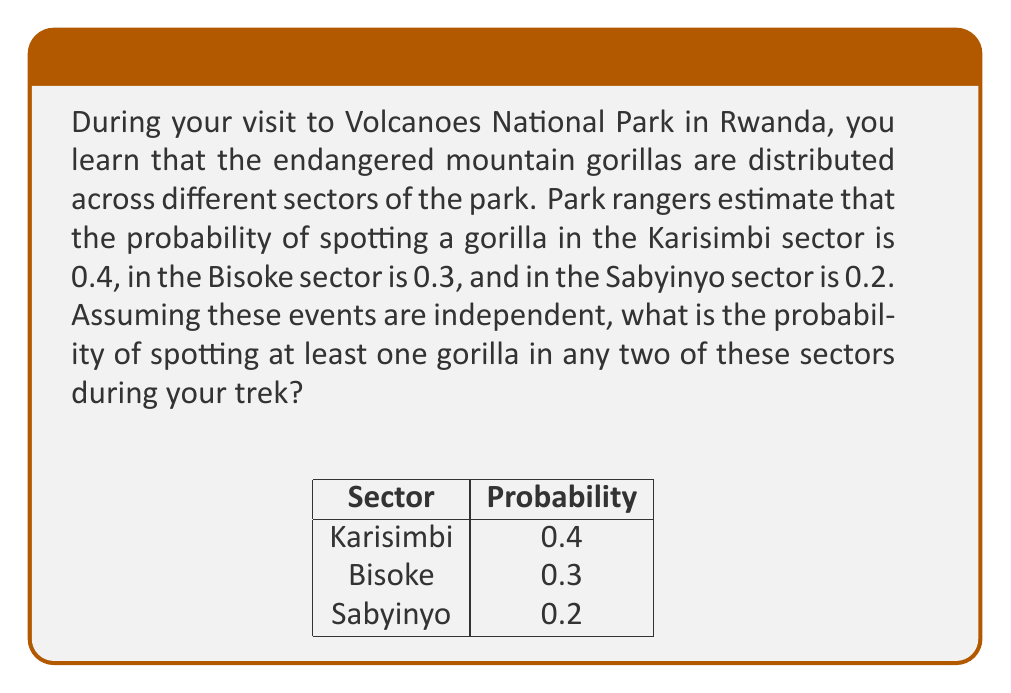Can you answer this question? Let's approach this step-by-step:

1) First, let's define our events:
   K: Spotting a gorilla in Karisimbi sector
   B: Spotting a gorilla in Bisoke sector
   S: Spotting a gorilla in Sabyinyo sector

2) We're given the following probabilities:
   P(K) = 0.4
   P(B) = 0.3
   P(S) = 0.2

3) We need to find the probability of spotting a gorilla in at least two sectors. It's easier to calculate the complement of this event: the probability of spotting a gorilla in one or zero sectors.

4) The probability of not spotting a gorilla in a sector is:
   P(not K) = 1 - 0.4 = 0.6
   P(not B) = 1 - 0.3 = 0.7
   P(not S) = 1 - 0.2 = 0.8

5) The probability of spotting no gorillas at all:
   P(no gorillas) = P(not K) × P(not B) × P(not S) = 0.6 × 0.7 × 0.8 = 0.336

6) The probability of spotting a gorilla in exactly one sector:
   P(only K) = 0.4 × 0.7 × 0.8 = 0.224
   P(only B) = 0.6 × 0.3 × 0.8 = 0.144
   P(only S) = 0.6 × 0.7 × 0.2 = 0.084

7) The total probability of spotting a gorilla in one or zero sectors:
   P(one or zero) = 0.336 + 0.224 + 0.144 + 0.084 = 0.788

8) Therefore, the probability of spotting at least one gorilla in any two sectors is:
   P(at least two) = 1 - P(one or zero) = 1 - 0.788 = 0.212
Answer: 0.212 